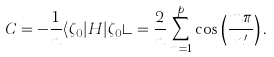<formula> <loc_0><loc_0><loc_500><loc_500>C = - \frac { 1 } { n } \langle \zeta _ { 0 } | H | \zeta _ { 0 } \rangle = \frac { 2 } { n } \sum _ { m = 1 } ^ { p } \cos \left ( \frac { m \pi } { n ^ { \prime } } \right ) .</formula> 